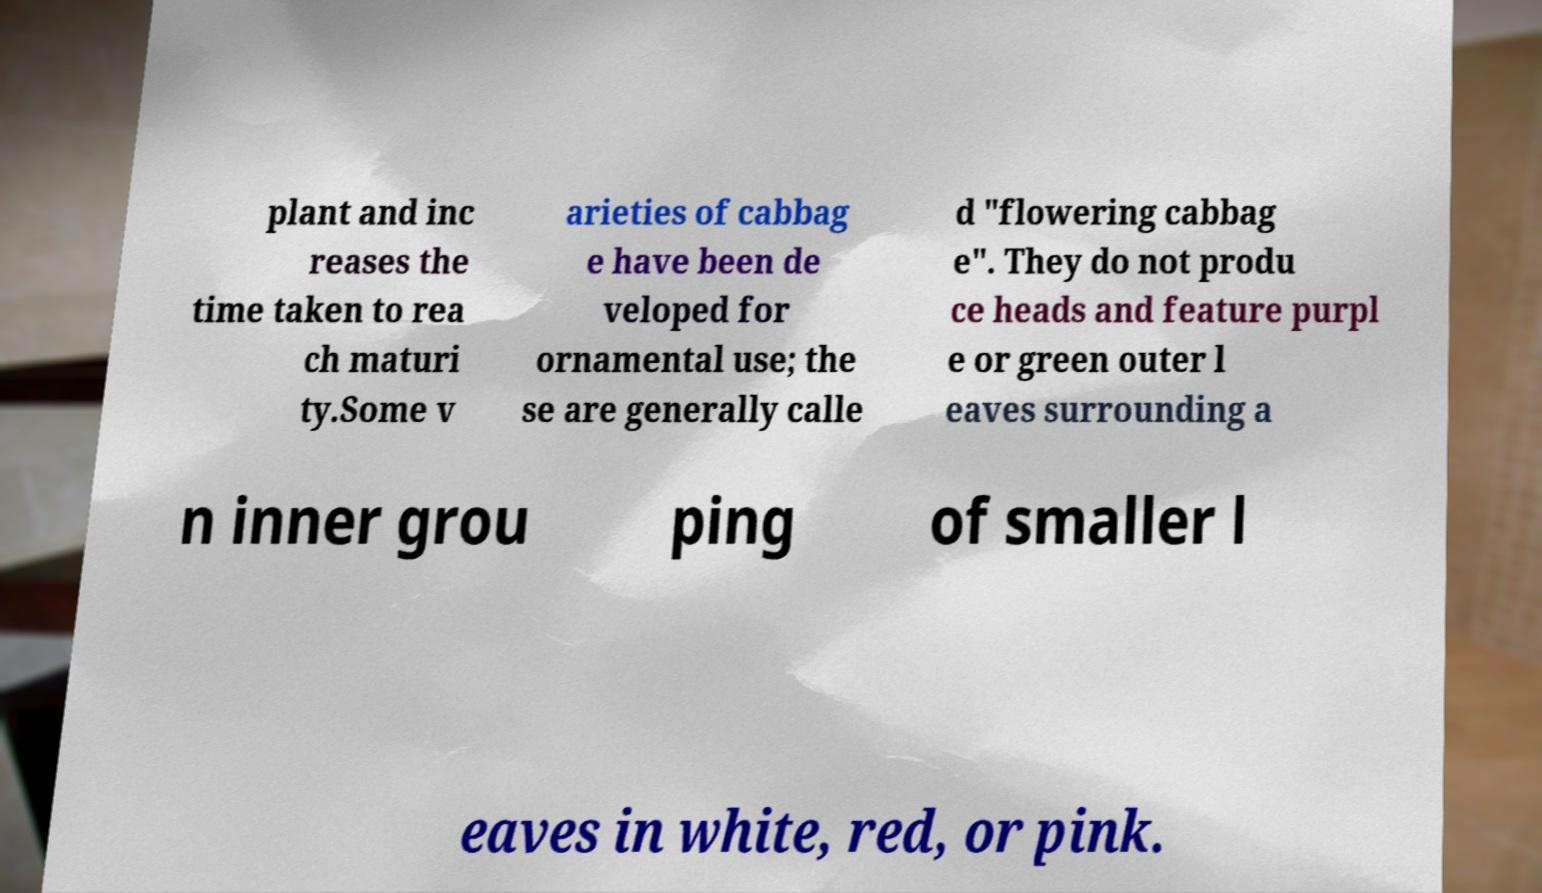Can you read and provide the text displayed in the image?This photo seems to have some interesting text. Can you extract and type it out for me? plant and inc reases the time taken to rea ch maturi ty.Some v arieties of cabbag e have been de veloped for ornamental use; the se are generally calle d "flowering cabbag e". They do not produ ce heads and feature purpl e or green outer l eaves surrounding a n inner grou ping of smaller l eaves in white, red, or pink. 